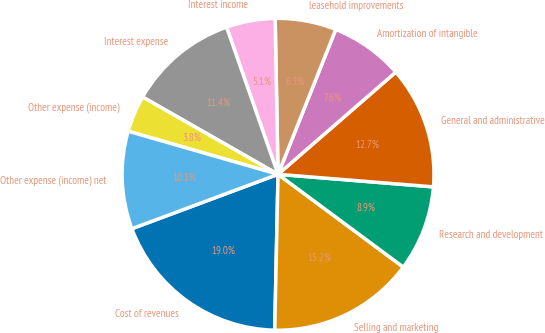<chart> <loc_0><loc_0><loc_500><loc_500><pie_chart><fcel>Cost of revenues<fcel>Selling and marketing<fcel>Research and development<fcel>General and administrative<fcel>Amortization of intangible<fcel>leasehold improvements<fcel>Interest income<fcel>Interest expense<fcel>Other expense (income)<fcel>Other expense (income) net<nl><fcel>18.99%<fcel>15.19%<fcel>8.86%<fcel>12.66%<fcel>7.59%<fcel>6.33%<fcel>5.06%<fcel>11.39%<fcel>3.8%<fcel>10.13%<nl></chart> 